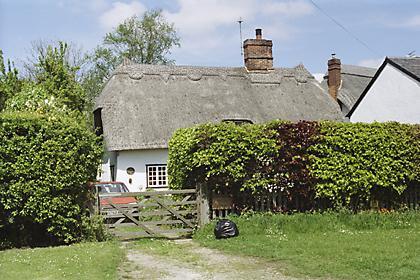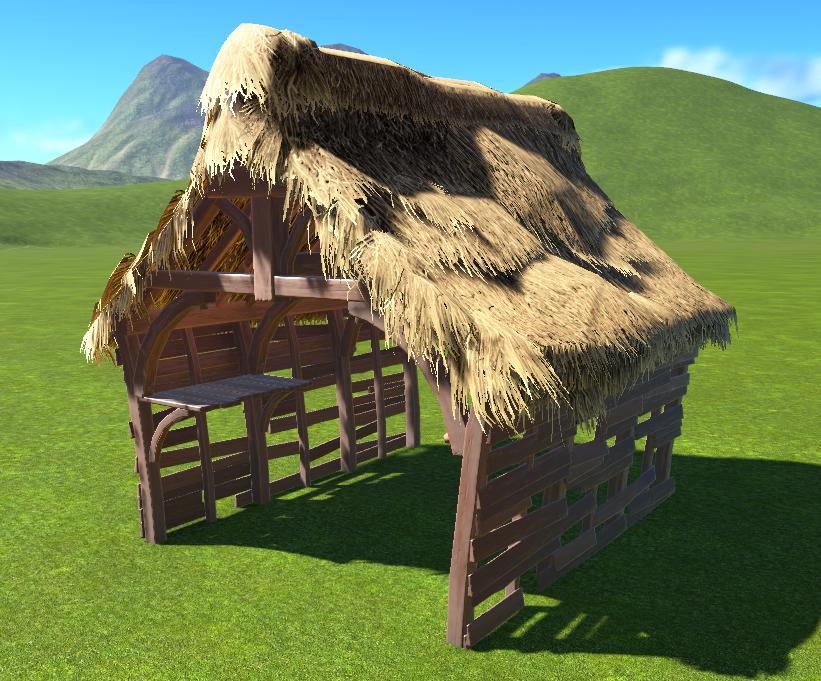The first image is the image on the left, the second image is the image on the right. For the images shown, is this caption "The right image shows a simple square structure with a sloping shaggy thatched roof that has a flat ridge on top, sitting on a green field with no landscaping around it." true? Answer yes or no. Yes. The first image is the image on the left, the second image is the image on the right. Given the left and right images, does the statement "In at least one image there is a small outside shed with hay for the roof and wood for the sides." hold true? Answer yes or no. Yes. 